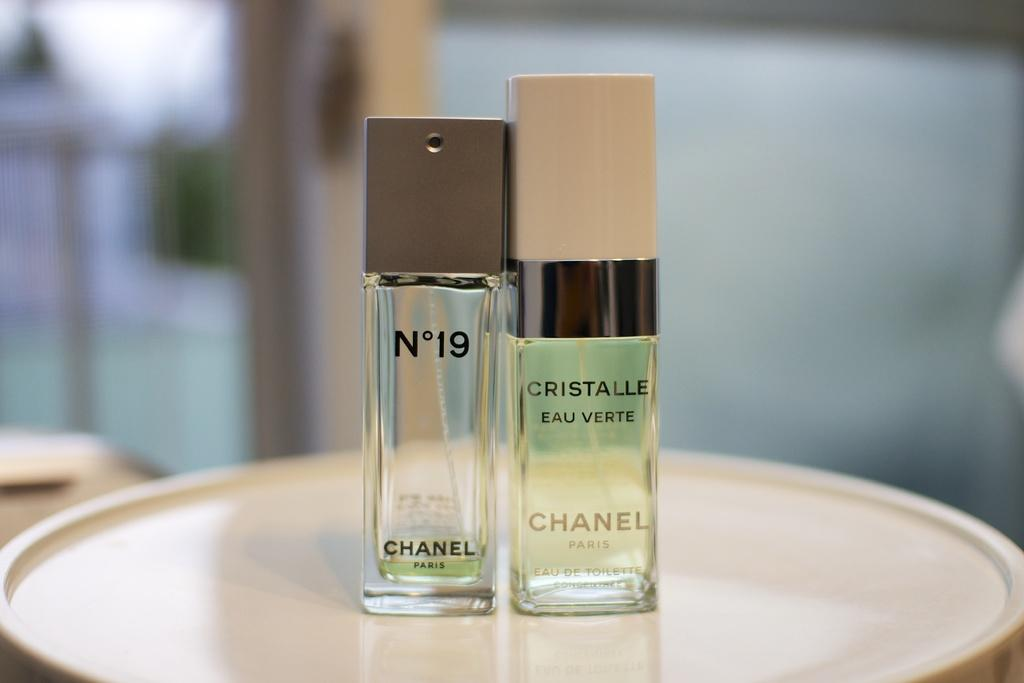<image>
Describe the image concisely. A bottle of N 19 perfume by Chanel. 